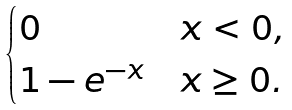<formula> <loc_0><loc_0><loc_500><loc_500>\begin{cases} 0 & x < 0 , \\ 1 - e ^ { - x } & x \geq 0 . \end{cases}</formula> 